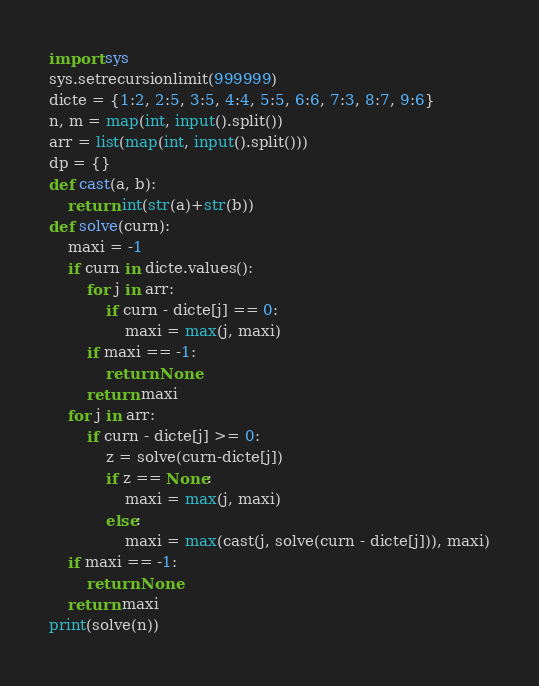Convert code to text. <code><loc_0><loc_0><loc_500><loc_500><_Python_>import sys
sys.setrecursionlimit(999999)
dicte = {1:2, 2:5, 3:5, 4:4, 5:5, 6:6, 7:3, 8:7, 9:6}
n, m = map(int, input().split())
arr = list(map(int, input().split()))
dp = {}
def cast(a, b):
    return int(str(a)+str(b))
def solve(curn):
    maxi = -1
    if curn in dicte.values():
        for j in arr:
            if curn - dicte[j] == 0:
                maxi = max(j, maxi)
        if maxi == -1:
            return None
        return maxi
    for j in arr:
        if curn - dicte[j] >= 0:
            z = solve(curn-dicte[j])
            if z == None:
                maxi = max(j, maxi)
            else:
                maxi = max(cast(j, solve(curn - dicte[j])), maxi)
    if maxi == -1:
        return None
    return maxi
print(solve(n))</code> 